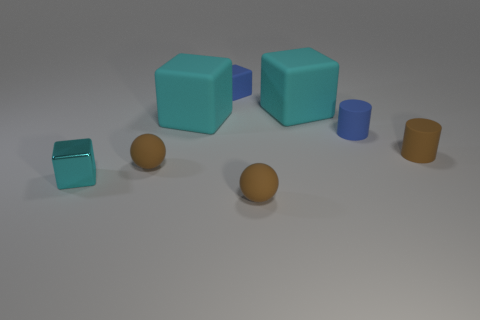How many objects are either large red shiny spheres or matte spheres in front of the blue rubber cylinder?
Provide a succinct answer. 2. Is there any other thing that has the same material as the tiny cyan block?
Give a very brief answer. No. The object that is the same color as the small matte block is what shape?
Make the answer very short. Cylinder. What material is the tiny blue cube?
Give a very brief answer. Rubber. Is the material of the tiny cyan thing the same as the small blue cylinder?
Ensure brevity in your answer.  No. How many shiny things are small brown cylinders or small brown spheres?
Keep it short and to the point. 0. There is a large cyan object to the left of the small blue rubber block; what shape is it?
Offer a very short reply. Cube. There is a blue cylinder that is made of the same material as the blue cube; what size is it?
Make the answer very short. Small. What shape is the tiny brown object that is left of the tiny brown matte cylinder and behind the small cyan metal object?
Give a very brief answer. Sphere. There is a tiny rubber ball in front of the small shiny cube; does it have the same color as the small rubber block?
Offer a terse response. No. 